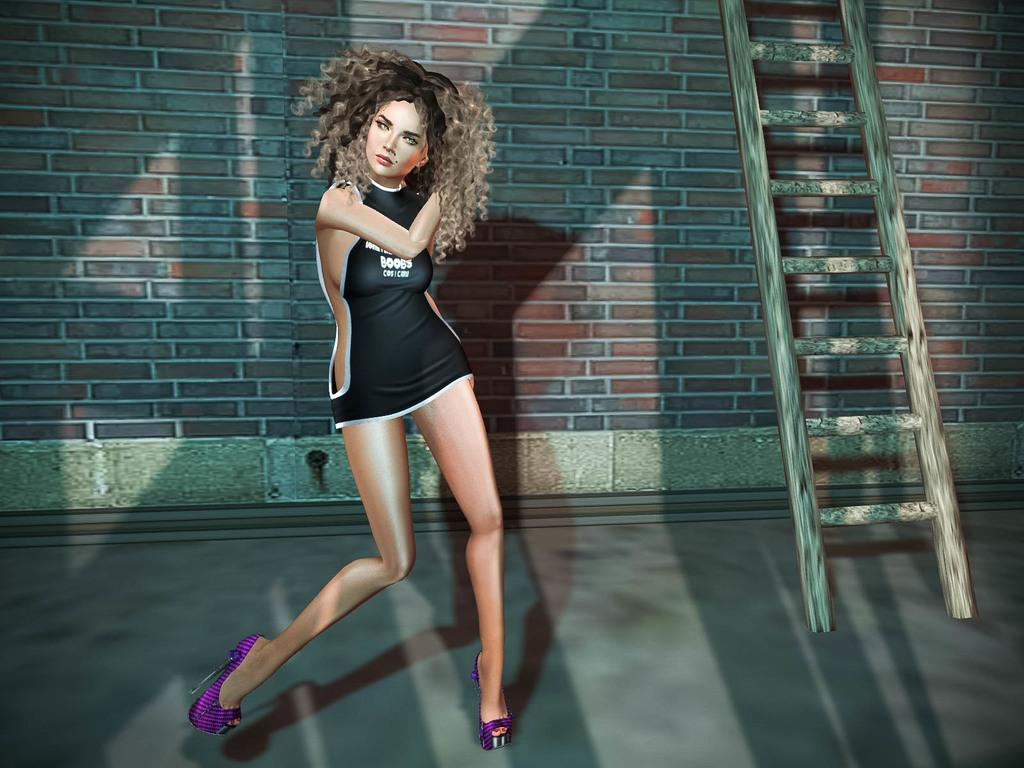<image>
Relay a brief, clear account of the picture shown. A cartoonish looking girl wearing a tiny dress that says boobs. 